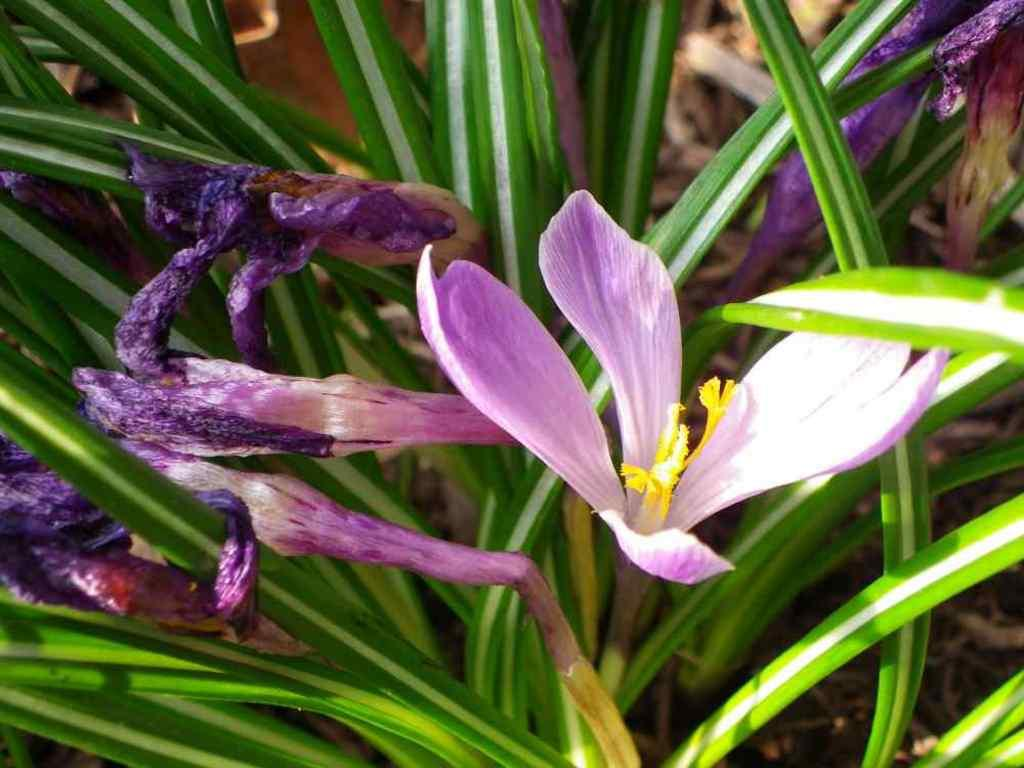What type of plant elements can be seen in the image? There are flowers, leaves, and stems in the image. What is the background of the image like? The background of the image has a blurred view. What type of fuel is being used by the ladybug in the image? There is no ladybug present in the image, so it is not possible to determine what type of fuel it might be using. 